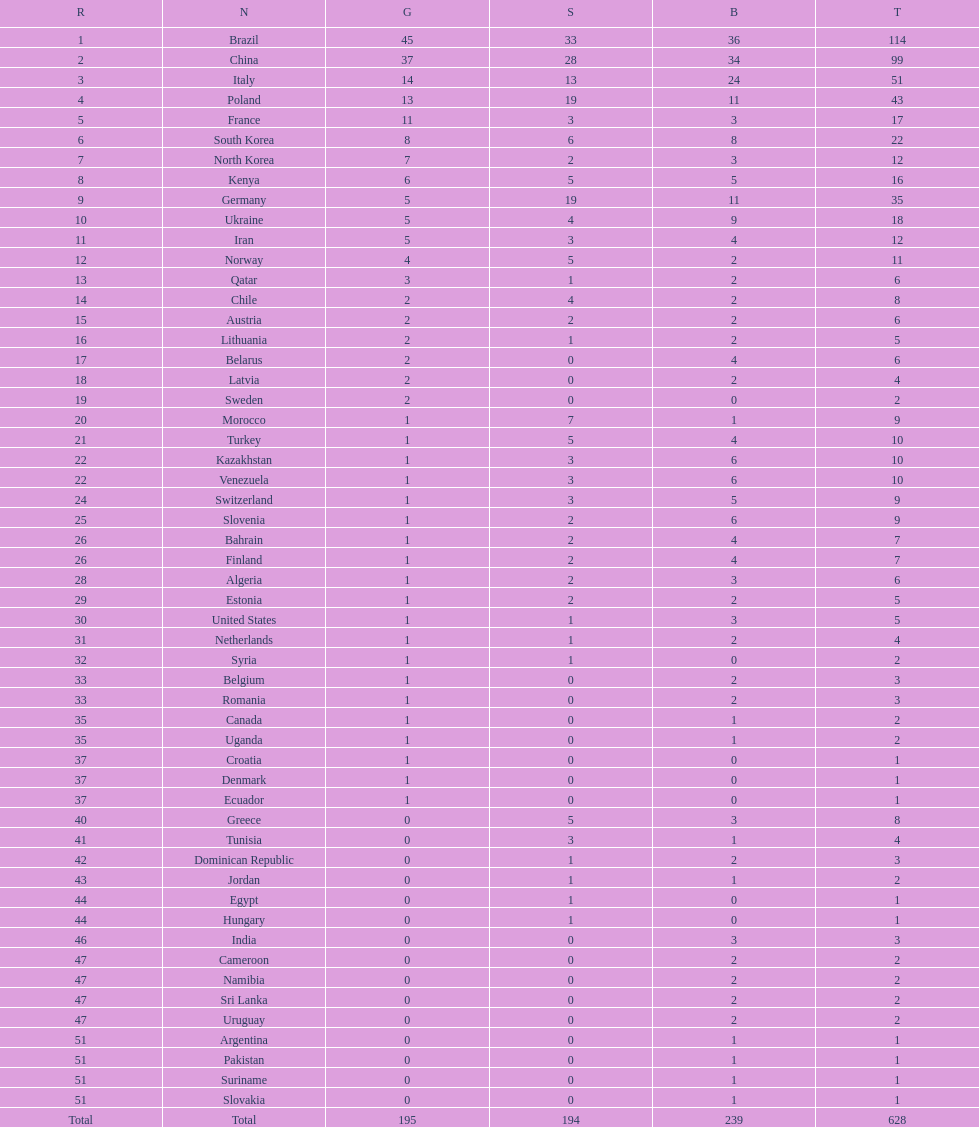How many gold medals were earned by germany? 5. 